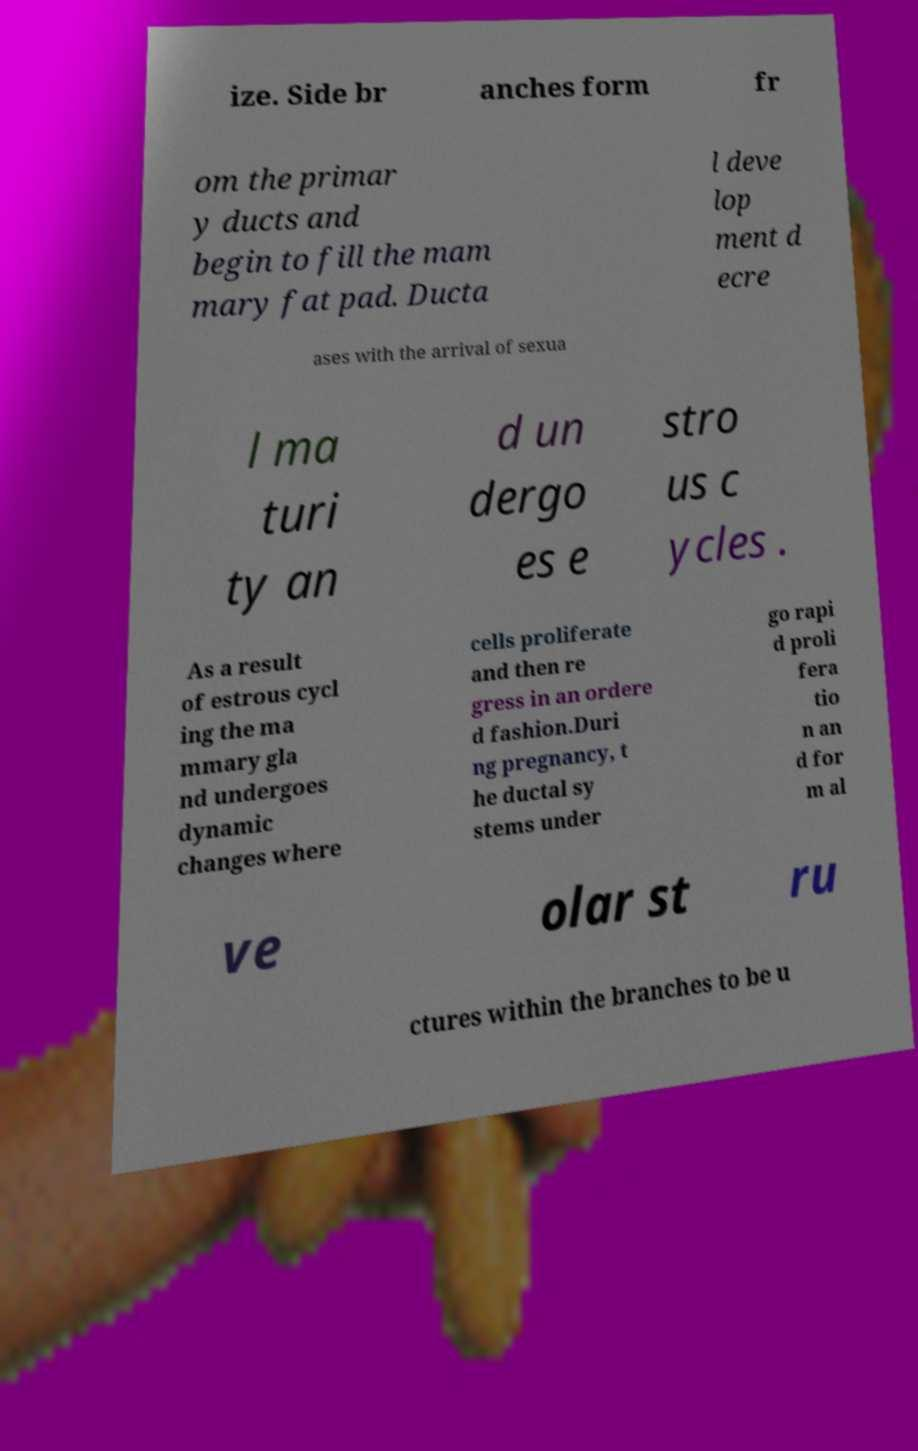I need the written content from this picture converted into text. Can you do that? ize. Side br anches form fr om the primar y ducts and begin to fill the mam mary fat pad. Ducta l deve lop ment d ecre ases with the arrival of sexua l ma turi ty an d un dergo es e stro us c ycles . As a result of estrous cycl ing the ma mmary gla nd undergoes dynamic changes where cells proliferate and then re gress in an ordere d fashion.Duri ng pregnancy, t he ductal sy stems under go rapi d proli fera tio n an d for m al ve olar st ru ctures within the branches to be u 